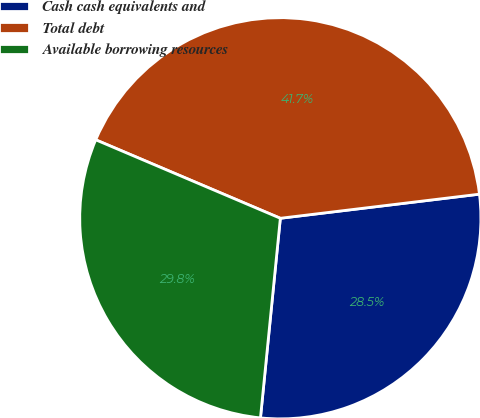Convert chart. <chart><loc_0><loc_0><loc_500><loc_500><pie_chart><fcel>Cash cash equivalents and<fcel>Total debt<fcel>Available borrowing resources<nl><fcel>28.5%<fcel>41.69%<fcel>29.82%<nl></chart> 